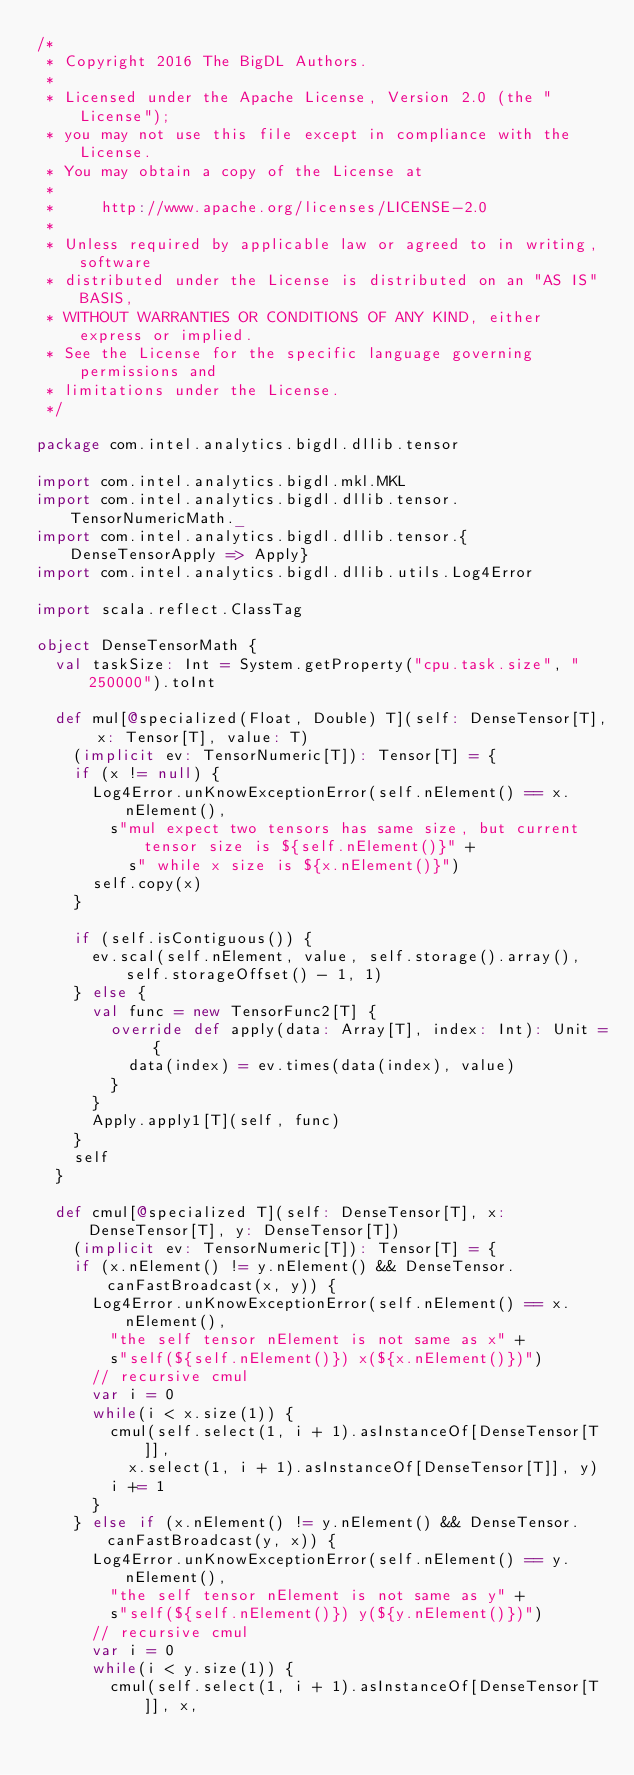Convert code to text. <code><loc_0><loc_0><loc_500><loc_500><_Scala_>/*
 * Copyright 2016 The BigDL Authors.
 *
 * Licensed under the Apache License, Version 2.0 (the "License");
 * you may not use this file except in compliance with the License.
 * You may obtain a copy of the License at
 *
 *     http://www.apache.org/licenses/LICENSE-2.0
 *
 * Unless required by applicable law or agreed to in writing, software
 * distributed under the License is distributed on an "AS IS" BASIS,
 * WITHOUT WARRANTIES OR CONDITIONS OF ANY KIND, either express or implied.
 * See the License for the specific language governing permissions and
 * limitations under the License.
 */

package com.intel.analytics.bigdl.dllib.tensor

import com.intel.analytics.bigdl.mkl.MKL
import com.intel.analytics.bigdl.dllib.tensor.TensorNumericMath._
import com.intel.analytics.bigdl.dllib.tensor.{DenseTensorApply => Apply}
import com.intel.analytics.bigdl.dllib.utils.Log4Error

import scala.reflect.ClassTag

object DenseTensorMath {
  val taskSize: Int = System.getProperty("cpu.task.size", "250000").toInt

  def mul[@specialized(Float, Double) T](self: DenseTensor[T], x: Tensor[T], value: T)
    (implicit ev: TensorNumeric[T]): Tensor[T] = {
    if (x != null) {
      Log4Error.unKnowExceptionError(self.nElement() == x.nElement(),
        s"mul expect two tensors has same size, but current tensor size is ${self.nElement()}" +
          s" while x size is ${x.nElement()}")
      self.copy(x)
    }

    if (self.isContiguous()) {
      ev.scal(self.nElement, value, self.storage().array(), self.storageOffset() - 1, 1)
    } else {
      val func = new TensorFunc2[T] {
        override def apply(data: Array[T], index: Int): Unit = {
          data(index) = ev.times(data(index), value)
        }
      }
      Apply.apply1[T](self, func)
    }
    self
  }

  def cmul[@specialized T](self: DenseTensor[T], x: DenseTensor[T], y: DenseTensor[T])
    (implicit ev: TensorNumeric[T]): Tensor[T] = {
    if (x.nElement() != y.nElement() && DenseTensor.canFastBroadcast(x, y)) {
      Log4Error.unKnowExceptionError(self.nElement() == x.nElement(),
        "the self tensor nElement is not same as x" +
        s"self(${self.nElement()}) x(${x.nElement()})")
      // recursive cmul
      var i = 0
      while(i < x.size(1)) {
        cmul(self.select(1, i + 1).asInstanceOf[DenseTensor[T]],
          x.select(1, i + 1).asInstanceOf[DenseTensor[T]], y)
        i += 1
      }
    } else if (x.nElement() != y.nElement() && DenseTensor.canFastBroadcast(y, x)) {
      Log4Error.unKnowExceptionError(self.nElement() == y.nElement(),
        "the self tensor nElement is not same as y" +
        s"self(${self.nElement()}) y(${y.nElement()})")
      // recursive cmul
      var i = 0
      while(i < y.size(1)) {
        cmul(self.select(1, i + 1).asInstanceOf[DenseTensor[T]], x,</code> 